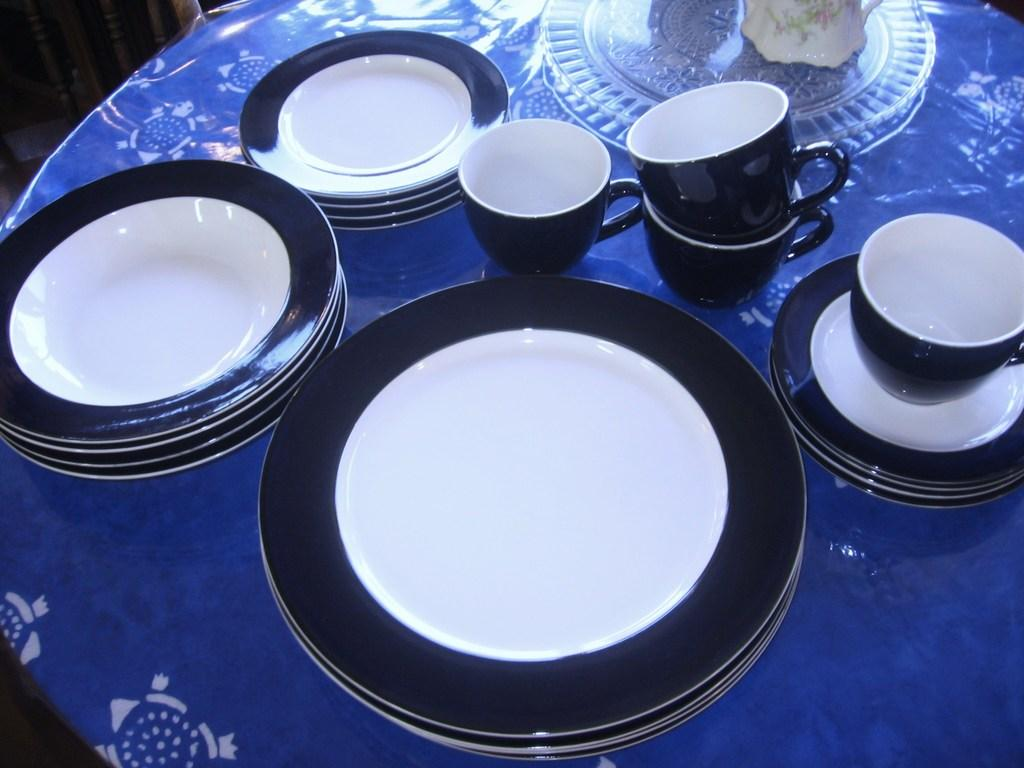What type of dishware can be seen in the image? There are plates, cups, and saucers in the image. Is there any dishware made of glass in the image? Yes, there is a glass plate in the image. What color is the table covering in the image? The table is covered with a blue color sheet. What book is the beginner reading in the image? There is no book or beginner present in the image; it only features dishware and a table covering. 